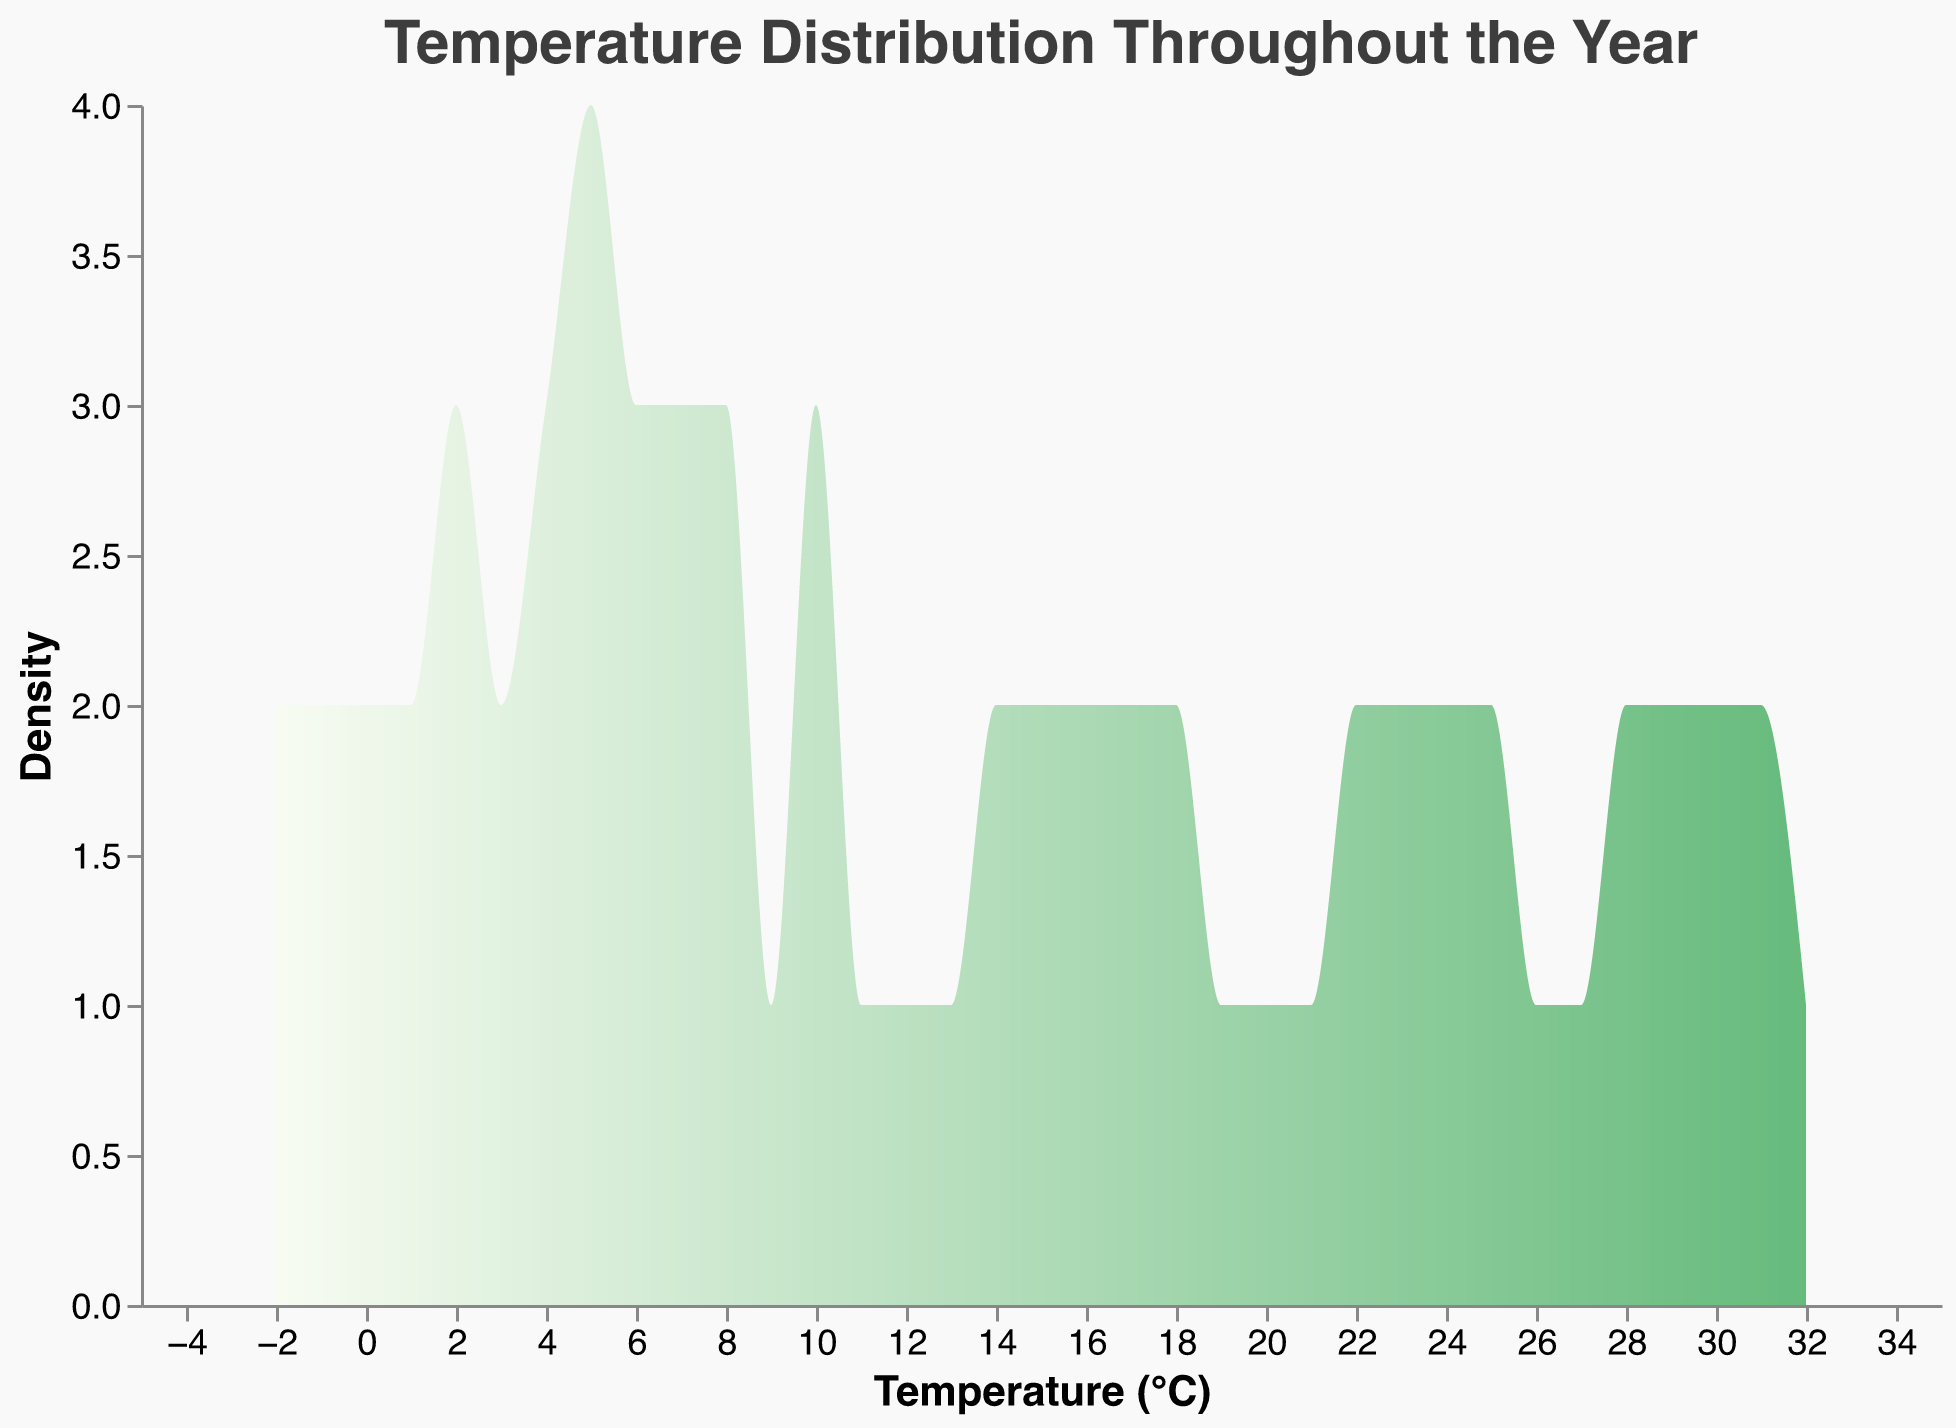What is the title of the density plot? The title of a plot is usually located at the top and provides a summary of the visualization's content. Here, the title is "Temperature Distribution Throughout the Year".
Answer: Temperature Distribution Throughout the Year What does the x-axis represent? The x-axis usually labels quantitative measurements in a density plot. Here, it indicates temperature in degrees Celsius.
Answer: Temperature (°C) What does the y-axis represent? The y-axis in a density plot indicates the density of occurrences of values represented on the x-axis. In this case, it shows the density of temperatures.
Answer: Density What is the range of temperatures shown in the plot? The range can be determined by looking at the minimum and maximum values on the x-axis. Here, it ranges from -2°C to 32°C.
Answer: -2°C to 32°C Which temperature has the highest density? To find the temperature with the highest density, look for the peak of the curve on the density plot. Here, it appears around 31°C.
Answer: 31°C Is there a temperature that corresponds to low density in the distribution? Temperatures with low density are represented by the lowest points on the curve. These occur around -2°C.
Answer: -2°C What is the overall trend in temperature density throughout the year? Examining the shape of the density plot shows the distribution of temperatures over the year. It appears there is a peak around higher temperatures (~30°C) and a smaller, secondary peak around the low temperatures (~5°C).
Answer: Generally, temperatures are more densely distributed around 30°C Which season likely contributes most to the highest density peak? Knowing that higher temperatures typically correspond to summer months, the highest density peak around 31°C likely corresponds to summer.
Answer: Summer How does the curve's gradient change from January to July? By looking at the density curve from lower (January) to higher (July) temperatures, the gradient becomes steeper as it approaches the peak temperatures in the middle of the year and then slopes back into lower temperatures.
Answer: It steepens approaching July and then slopes back What can be inferred about the variability in temperatures? To infer variability, observe the width of the peaks. The wider the peaks, the more variable the temperatures in those ranges are. The plot shows high variability at peak temperatures around 30°C and less at extreme low or high temperatures.
Answer: High variability at mid-range temperatures and low variability at extremes 